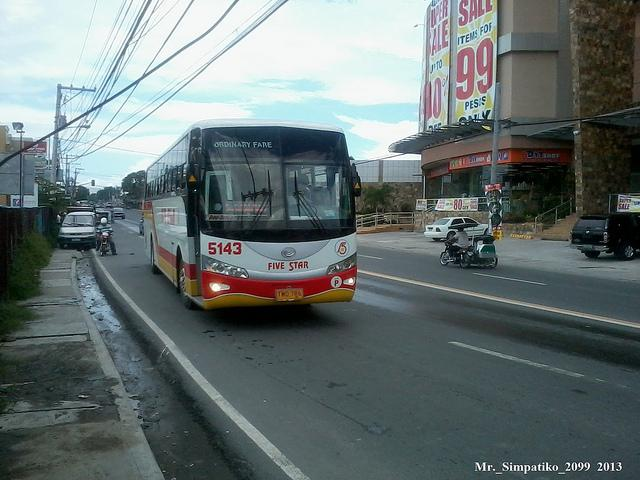What type of sign is on the building? sale 